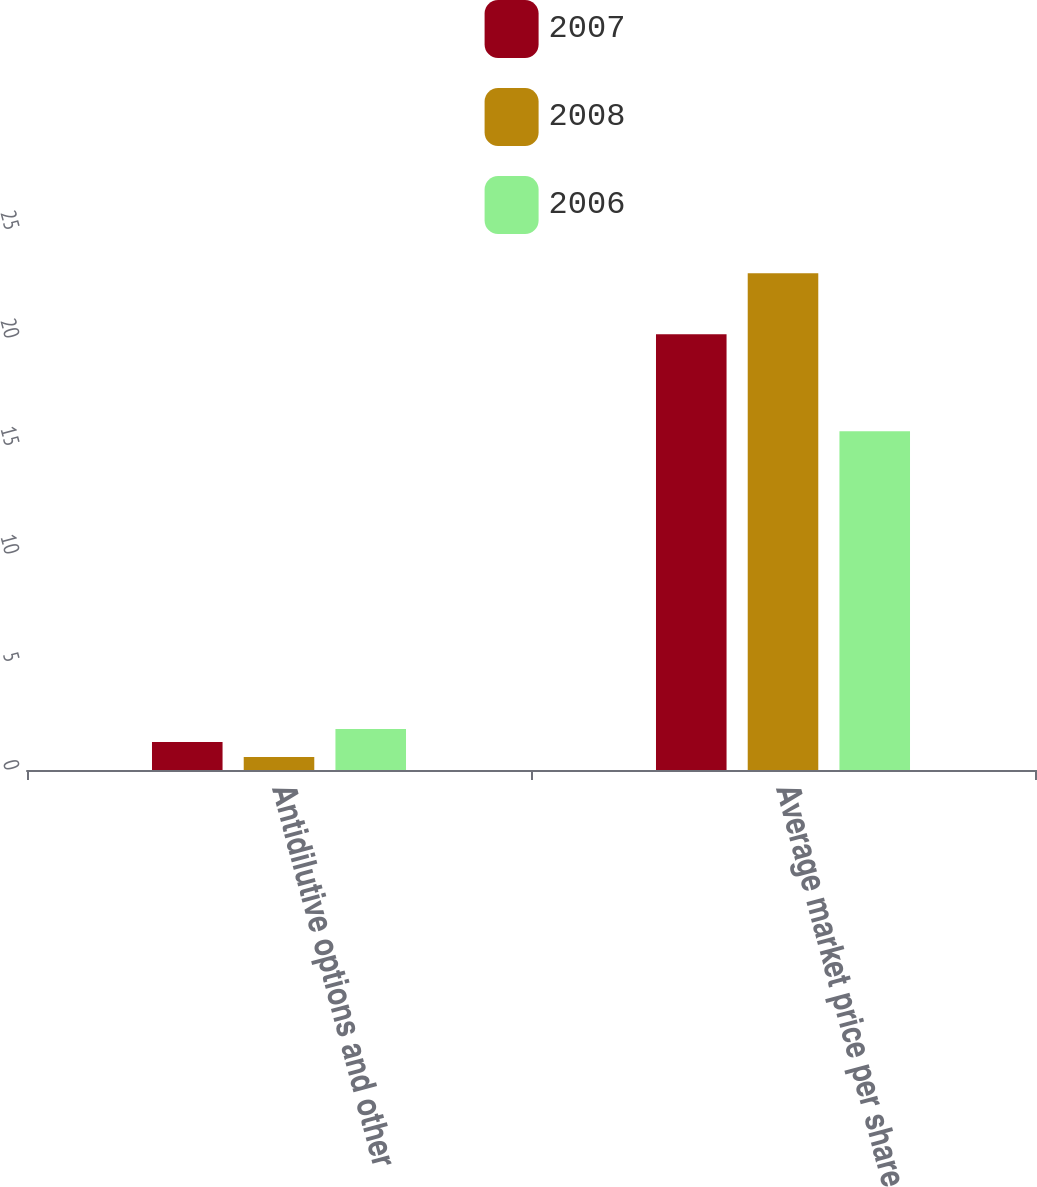Convert chart. <chart><loc_0><loc_0><loc_500><loc_500><stacked_bar_chart><ecel><fcel>Antidilutive options and other<fcel>Average market price per share<nl><fcel>2007<fcel>1.3<fcel>20.17<nl><fcel>2008<fcel>0.6<fcel>23<nl><fcel>2006<fcel>1.9<fcel>15.68<nl></chart> 